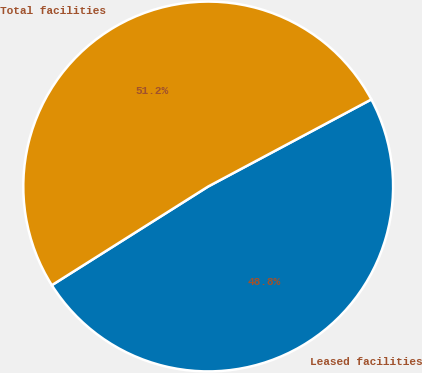Convert chart to OTSL. <chart><loc_0><loc_0><loc_500><loc_500><pie_chart><fcel>Leased facilities<fcel>Total facilities<nl><fcel>48.84%<fcel>51.16%<nl></chart> 